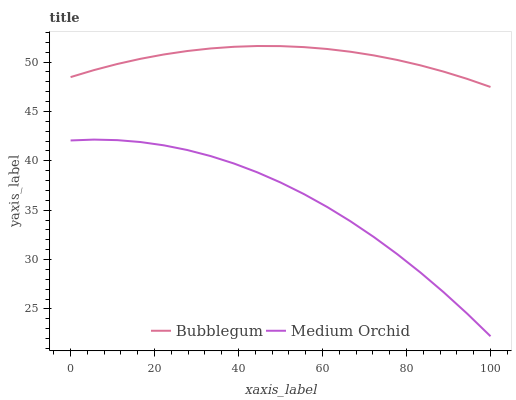Does Medium Orchid have the minimum area under the curve?
Answer yes or no. Yes. Does Bubblegum have the maximum area under the curve?
Answer yes or no. Yes. Does Bubblegum have the minimum area under the curve?
Answer yes or no. No. Is Bubblegum the smoothest?
Answer yes or no. Yes. Is Medium Orchid the roughest?
Answer yes or no. Yes. Is Bubblegum the roughest?
Answer yes or no. No. Does Medium Orchid have the lowest value?
Answer yes or no. Yes. Does Bubblegum have the lowest value?
Answer yes or no. No. Does Bubblegum have the highest value?
Answer yes or no. Yes. Is Medium Orchid less than Bubblegum?
Answer yes or no. Yes. Is Bubblegum greater than Medium Orchid?
Answer yes or no. Yes. Does Medium Orchid intersect Bubblegum?
Answer yes or no. No. 